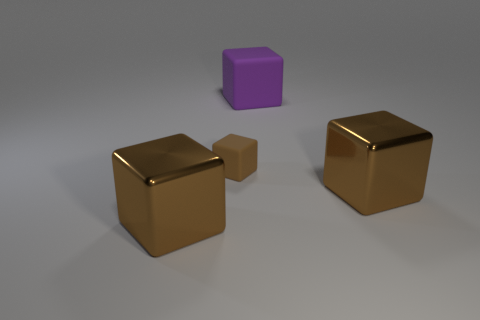How many brown cubes must be subtracted to get 1 brown cubes? 2 Subtract all purple matte blocks. How many blocks are left? 3 Add 1 green shiny objects. How many objects exist? 5 Subtract all brown blocks. How many blocks are left? 1 Add 1 brown rubber cubes. How many brown rubber cubes are left? 2 Add 2 big green cubes. How many big green cubes exist? 2 Subtract 0 blue spheres. How many objects are left? 4 Subtract 4 cubes. How many cubes are left? 0 Subtract all green blocks. Subtract all red spheres. How many blocks are left? 4 Subtract all gray spheres. How many brown cubes are left? 3 